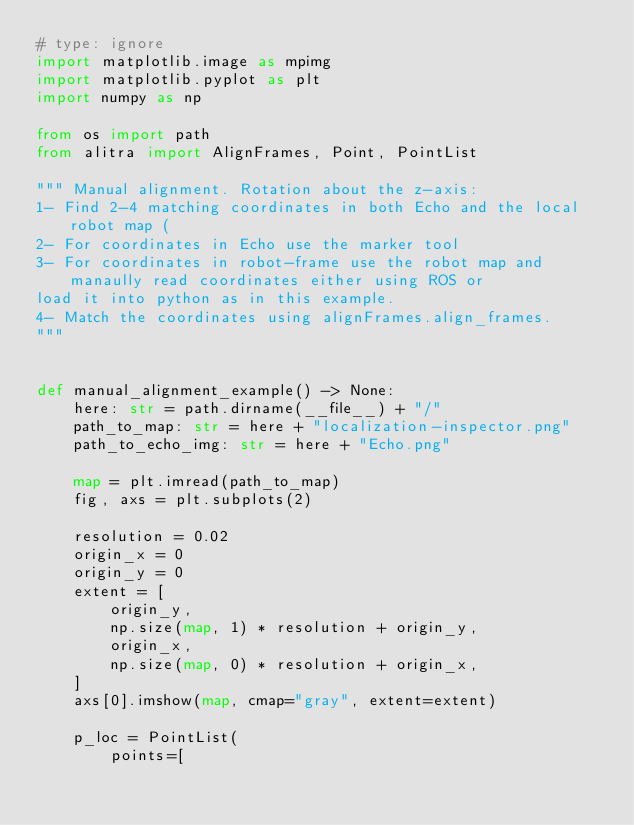<code> <loc_0><loc_0><loc_500><loc_500><_Python_># type: ignore
import matplotlib.image as mpimg
import matplotlib.pyplot as plt
import numpy as np

from os import path
from alitra import AlignFrames, Point, PointList

""" Manual alignment. Rotation about the z-axis:
1- Find 2-4 matching coordinates in both Echo and the local robot map (
2- For coordinates in Echo use the marker tool
3- For coordinates in robot-frame use the robot map and manaully read coordinates either using ROS or
load it into python as in this example.
4- Match the coordinates using alignFrames.align_frames.
"""


def manual_alignment_example() -> None:
    here: str = path.dirname(__file__) + "/"
    path_to_map: str = here + "localization-inspector.png"
    path_to_echo_img: str = here + "Echo.png"

    map = plt.imread(path_to_map)
    fig, axs = plt.subplots(2)

    resolution = 0.02
    origin_x = 0
    origin_y = 0
    extent = [
        origin_y,
        np.size(map, 1) * resolution + origin_y,
        origin_x,
        np.size(map, 0) * resolution + origin_x,
    ]
    axs[0].imshow(map, cmap="gray", extent=extent)

    p_loc = PointList(
        points=[</code> 